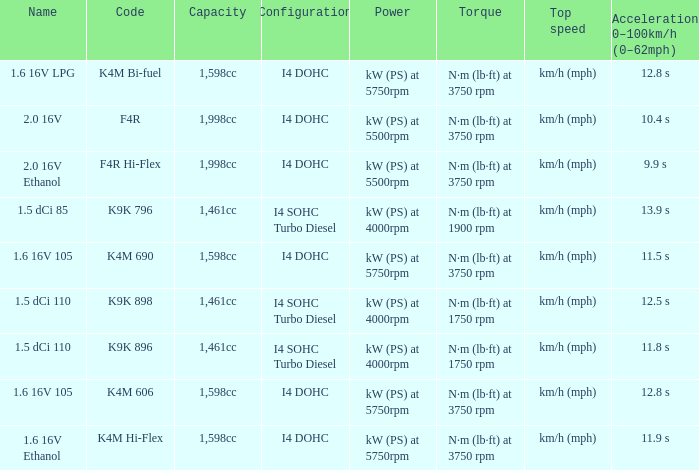What is the code of 1.5 dci 110, which has a capacity of 1,461cc? K9K 896, K9K 898. 